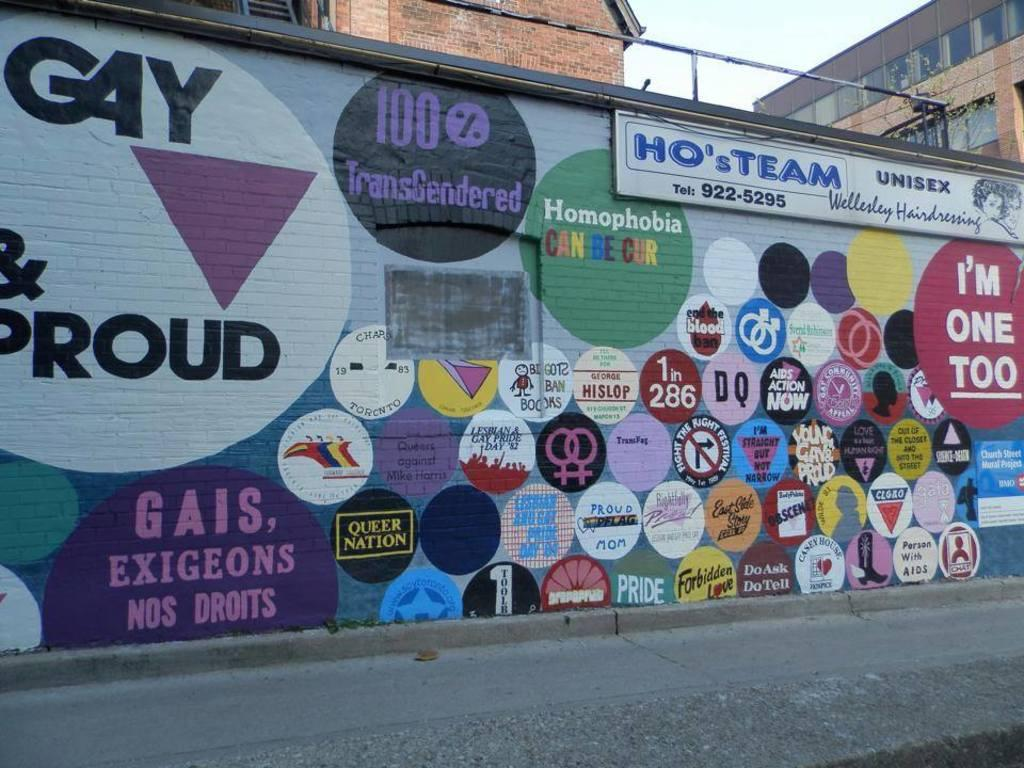<image>
Give a short and clear explanation of the subsequent image. An LGBTQ wall which states Gay and Proud. 